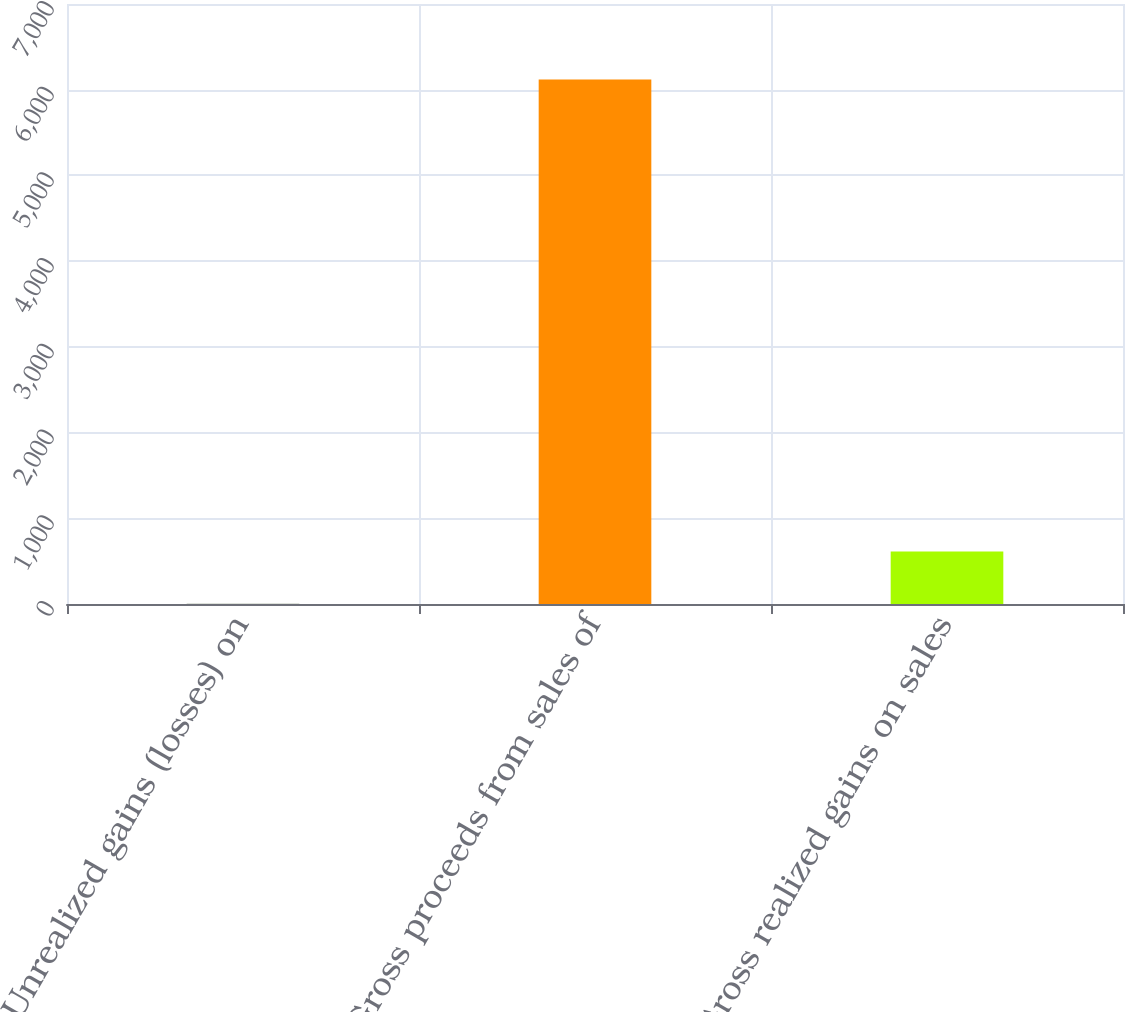Convert chart to OTSL. <chart><loc_0><loc_0><loc_500><loc_500><bar_chart><fcel>Unrealized gains (losses) on<fcel>Gross proceeds from sales of<fcel>Gross realized gains on sales<nl><fcel>2<fcel>6119<fcel>613.7<nl></chart> 